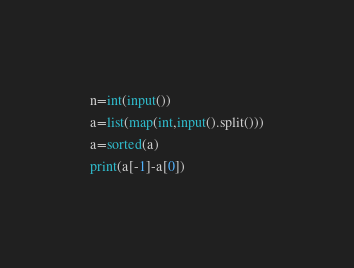<code> <loc_0><loc_0><loc_500><loc_500><_Python_>n=int(input())
a=list(map(int,input().split()))
a=sorted(a)
print(a[-1]-a[0])</code> 